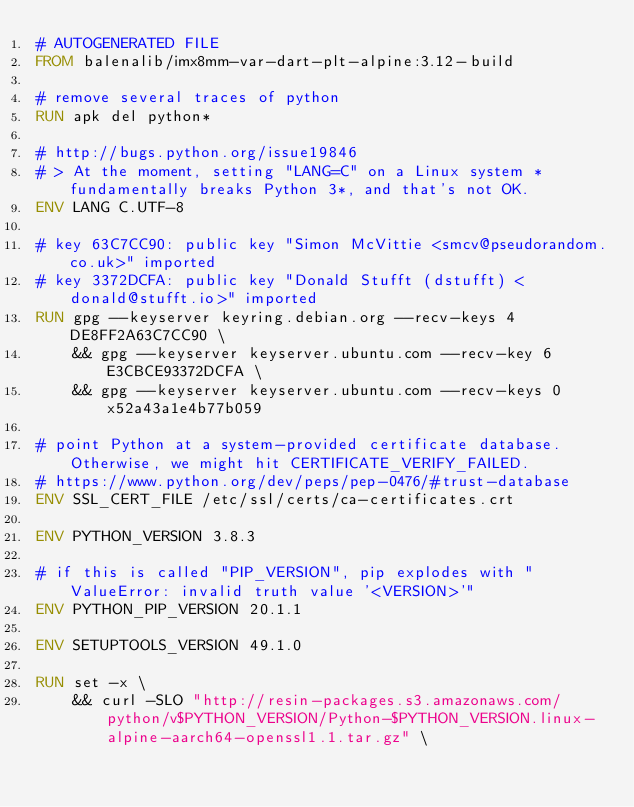Convert code to text. <code><loc_0><loc_0><loc_500><loc_500><_Dockerfile_># AUTOGENERATED FILE
FROM balenalib/imx8mm-var-dart-plt-alpine:3.12-build

# remove several traces of python
RUN apk del python*

# http://bugs.python.org/issue19846
# > At the moment, setting "LANG=C" on a Linux system *fundamentally breaks Python 3*, and that's not OK.
ENV LANG C.UTF-8

# key 63C7CC90: public key "Simon McVittie <smcv@pseudorandom.co.uk>" imported
# key 3372DCFA: public key "Donald Stufft (dstufft) <donald@stufft.io>" imported
RUN gpg --keyserver keyring.debian.org --recv-keys 4DE8FF2A63C7CC90 \
	&& gpg --keyserver keyserver.ubuntu.com --recv-key 6E3CBCE93372DCFA \
	&& gpg --keyserver keyserver.ubuntu.com --recv-keys 0x52a43a1e4b77b059

# point Python at a system-provided certificate database. Otherwise, we might hit CERTIFICATE_VERIFY_FAILED.
# https://www.python.org/dev/peps/pep-0476/#trust-database
ENV SSL_CERT_FILE /etc/ssl/certs/ca-certificates.crt

ENV PYTHON_VERSION 3.8.3

# if this is called "PIP_VERSION", pip explodes with "ValueError: invalid truth value '<VERSION>'"
ENV PYTHON_PIP_VERSION 20.1.1

ENV SETUPTOOLS_VERSION 49.1.0

RUN set -x \
	&& curl -SLO "http://resin-packages.s3.amazonaws.com/python/v$PYTHON_VERSION/Python-$PYTHON_VERSION.linux-alpine-aarch64-openssl1.1.tar.gz" \</code> 